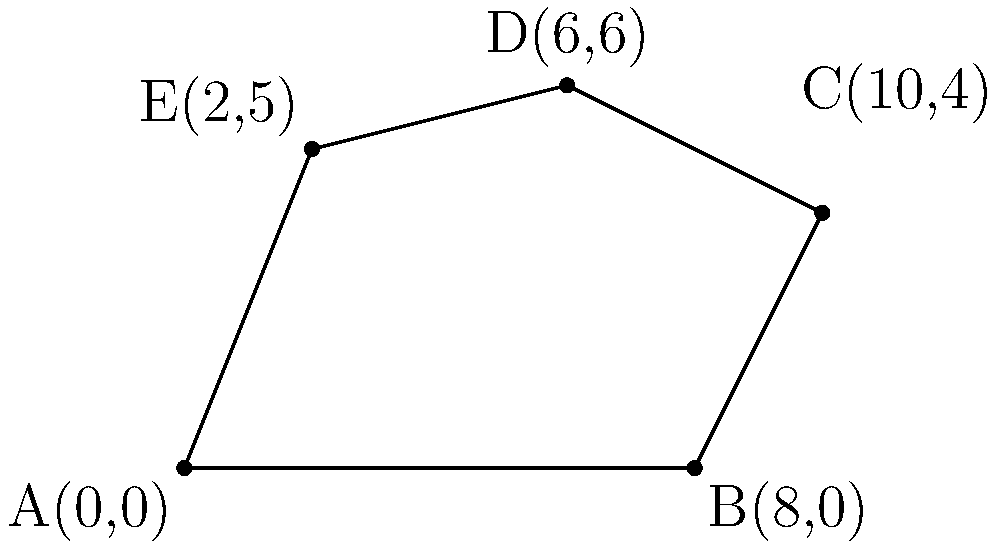You have an irregularly shaped pasture represented by the polygon ABCDE in the coordinate system. Calculate the area of this pasture to determine the optimal fencing needed to protect your livestock from predators. The coordinates of the vertices are A(0,0), B(8,0), C(10,4), D(6,6), and E(2,5). What is the area of the pasture in square units? To find the area of this irregular polygon, we can use the Shoelace formula (also known as the surveyor's formula). The steps are as follows:

1) First, let's arrange the coordinates in order:
   (x₁, y₁) = (0, 0)
   (x₂, y₂) = (8, 0)
   (x₃, y₃) = (10, 4)
   (x₄, y₄) = (6, 6)
   (x₅, y₅) = (2, 5)

2) The Shoelace formula is:
   Area = $\frac{1}{2}|((x_1y_2 + x_2y_3 + x_3y_4 + x_4y_5 + x_5y_1) - (y_1x_2 + y_2x_3 + y_3x_4 + y_4x_5 + y_5x_1))|$

3) Let's calculate each part:
   $(x_1y_2 + x_2y_3 + x_3y_4 + x_4y_5 + x_5y_1)$
   $= (0 \cdot 0) + (8 \cdot 4) + (10 \cdot 6) + (6 \cdot 5) + (2 \cdot 0) = 32 + 60 + 30 = 122$

   $(y_1x_2 + y_2x_3 + y_3x_4 + y_4x_5 + y_5x_1)$
   $= (0 \cdot 8) + (0 \cdot 10) + (4 \cdot 6) + (6 \cdot 2) + (5 \cdot 0) = 24 + 12 = 36$

4) Subtracting:
   $122 - 36 = 86$

5) Taking the absolute value and dividing by 2:
   Area = $\frac{1}{2}|86| = 43$

Therefore, the area of the pasture is 43 square units.
Answer: 43 square units 